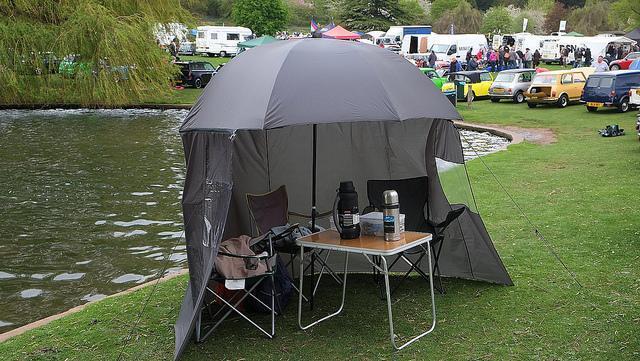How many chairs are there?
Give a very brief answer. 3. 